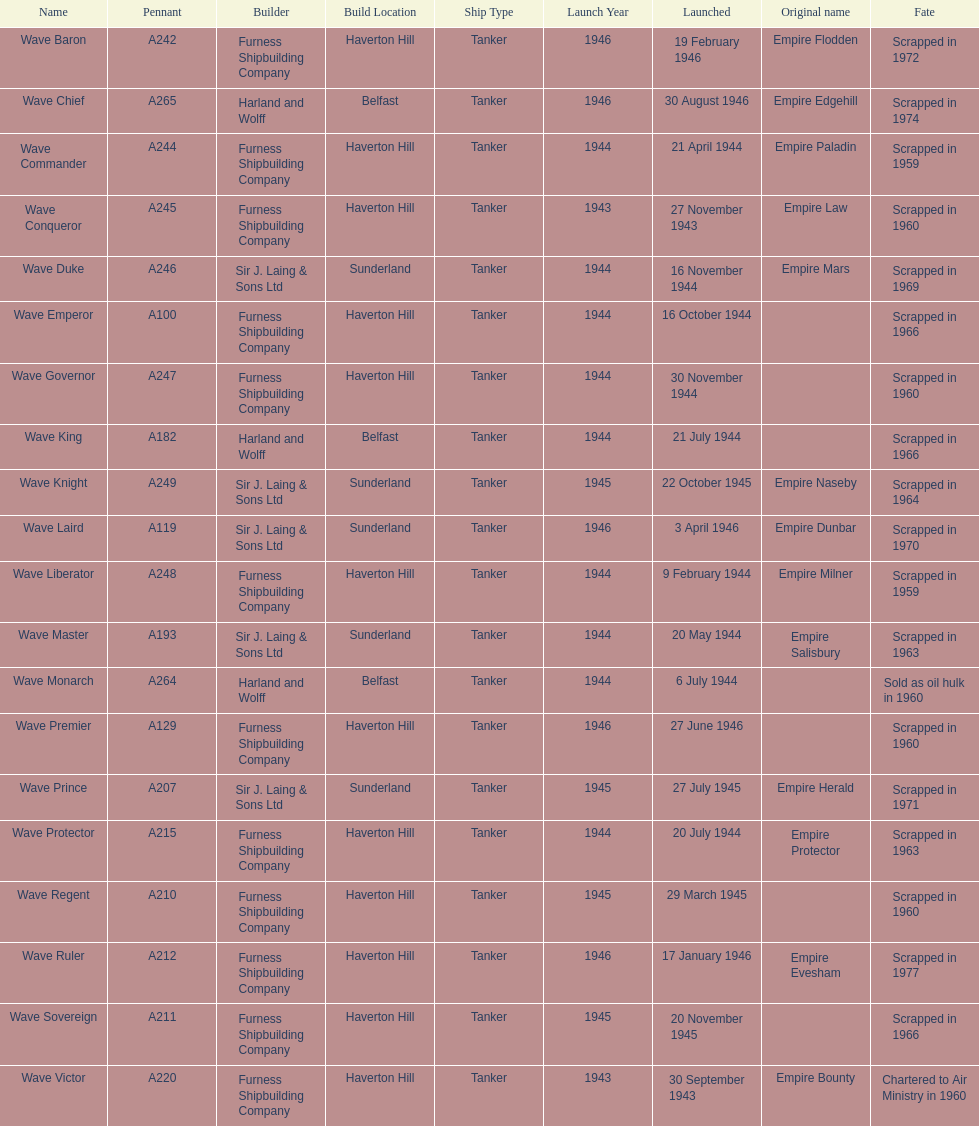What is the title of the most recent ship that was demolished? Wave Ruler. 